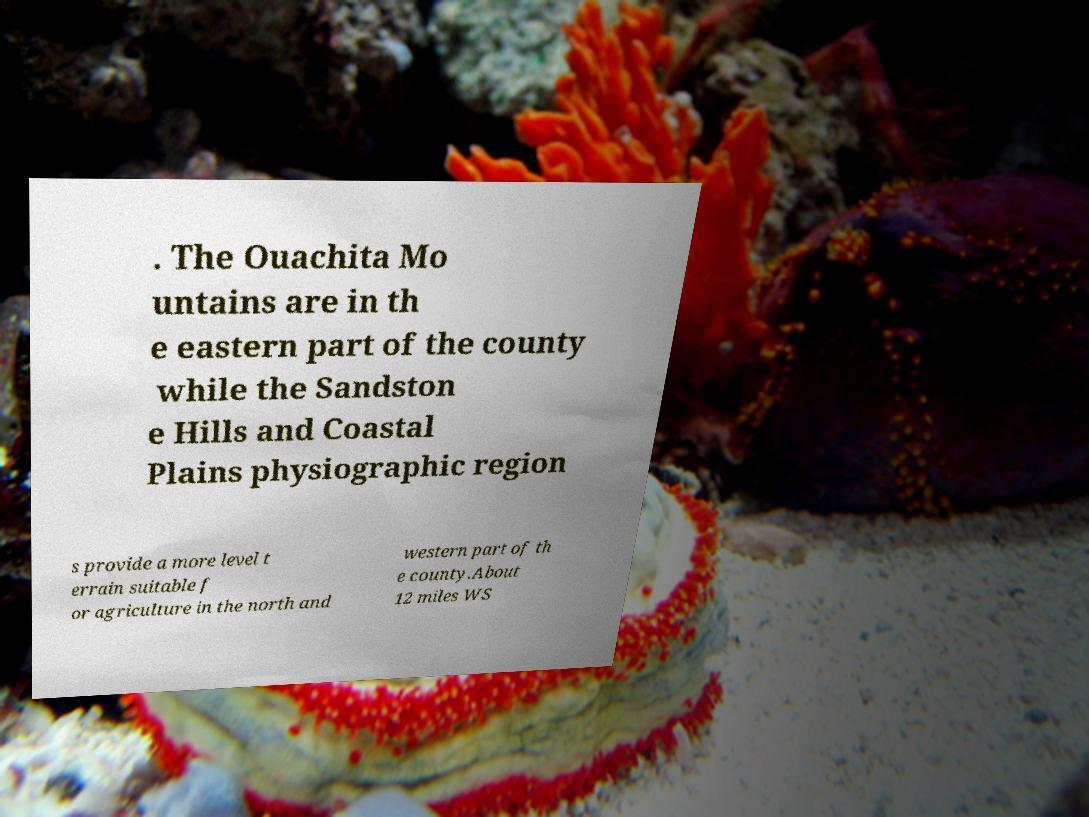Please identify and transcribe the text found in this image. . The Ouachita Mo untains are in th e eastern part of the county while the Sandston e Hills and Coastal Plains physiographic region s provide a more level t errain suitable f or agriculture in the north and western part of th e county.About 12 miles WS 